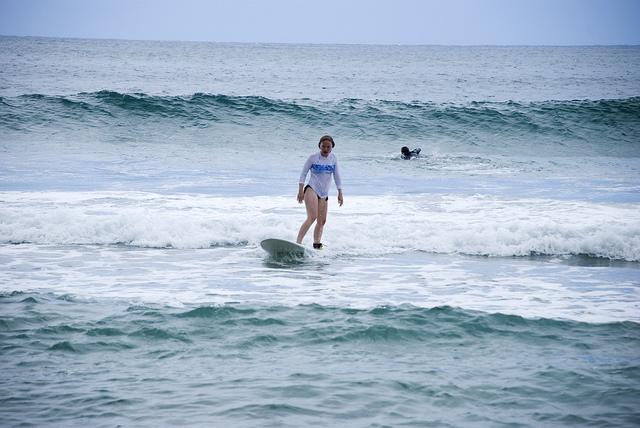What color is the wave?
Answer briefly. Blue. What position is the girl in?
Keep it brief. Standing. What color is the board?
Give a very brief answer. White. Where is the woman surfing?
Short answer required. Ocean. Is there a shark visible?
Write a very short answer. No. How many surfers are present?
Keep it brief. 2. Is this dog a good surfer?
Concise answer only. No. Is the surfer riding a wave?
Quick response, please. No. Is the girl learning to surf?
Write a very short answer. Yes. What color shirt is the person wearing?
Keep it brief. White. What is the woman holding?
Concise answer only. Nothing. Is this a photo from midday?
Short answer required. Yes. How many people are in the water?
Short answer required. 2. Are there large waves?
Concise answer only. No. 